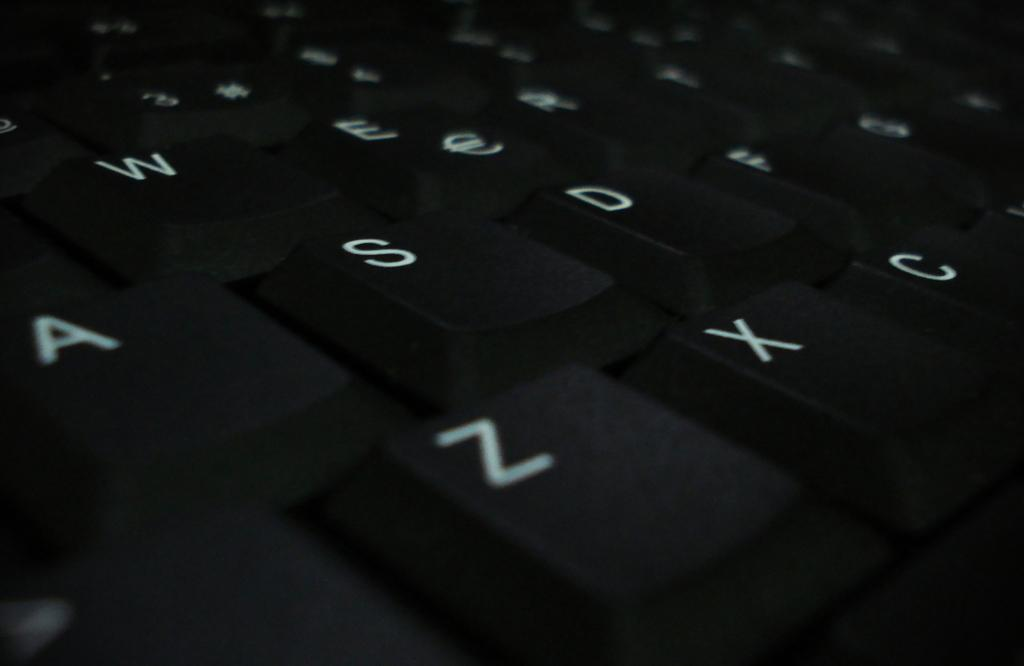<image>
Present a compact description of the photo's key features. A close up of the A, S, Z, and X keys on a keyboard. 